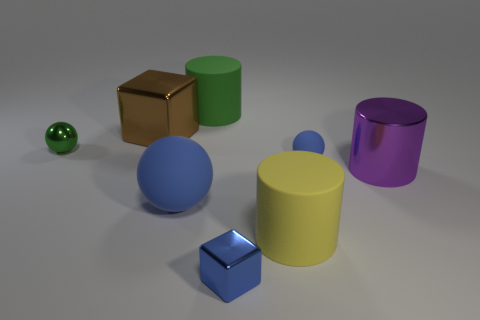What is the color of the large rubber thing that is right of the big blue thing and in front of the brown thing?
Provide a succinct answer. Yellow. Are there more cylinders on the right side of the yellow thing than big matte cylinders that are on the right side of the large green matte cylinder?
Your response must be concise. No. There is a shiny object behind the green ball; is its size the same as the green sphere?
Offer a very short reply. No. There is a blue matte ball that is behind the purple metal thing right of the big matte ball; how many large objects are on the left side of it?
Your answer should be compact. 4. There is a rubber object that is to the right of the big blue ball and in front of the purple metallic cylinder; what is its size?
Offer a very short reply. Large. What number of other objects are there of the same shape as the tiny blue metal object?
Your answer should be very brief. 1. There is a large blue rubber object; what number of tiny blue metallic blocks are on the left side of it?
Make the answer very short. 0. Is the number of small matte objects that are in front of the large blue ball less than the number of balls that are right of the large green cylinder?
Provide a short and direct response. Yes. There is a tiny green shiny object in front of the cylinder on the left side of the small shiny object in front of the yellow cylinder; what is its shape?
Provide a short and direct response. Sphere. What shape is the large object that is on the right side of the brown metal block and behind the green metal sphere?
Give a very brief answer. Cylinder. 